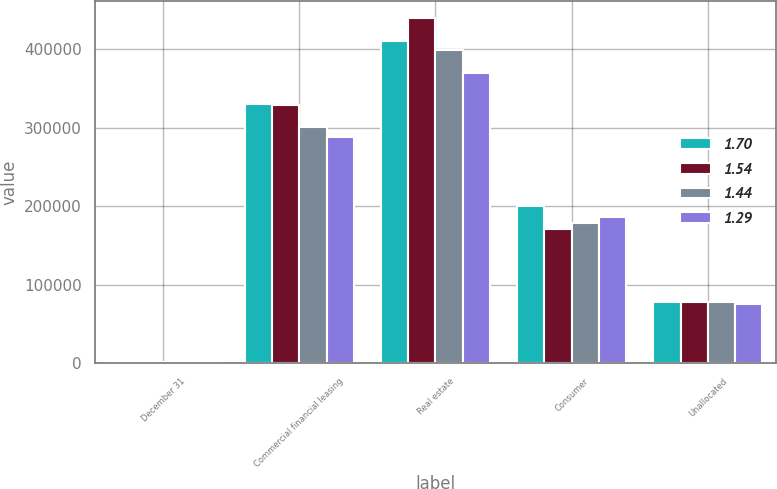Convert chart. <chart><loc_0><loc_0><loc_500><loc_500><stacked_bar_chart><ecel><fcel>December 31<fcel>Commercial financial leasing<fcel>Real estate<fcel>Consumer<fcel>Unallocated<nl><fcel>1.7<fcel>2018<fcel>330055<fcel>410780<fcel>200564<fcel>78045<nl><fcel>1.54<fcel>2017<fcel>328599<fcel>439490<fcel>170809<fcel>78300<nl><fcel>1.44<fcel>2015<fcel>300404<fcel>399069<fcel>178320<fcel>78199<nl><fcel>1.29<fcel>2014<fcel>288038<fcel>369837<fcel>186033<fcel>75654<nl></chart> 